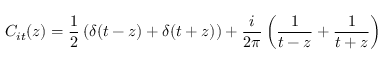Convert formula to latex. <formula><loc_0><loc_0><loc_500><loc_500>C _ { i t } ( z ) = \frac { 1 } { 2 } \left ( \delta ( t - z ) + \delta ( t + z ) \right ) + \frac { i } { 2 \pi } \left ( \frac { 1 } { t - z } + \frac { 1 } { t + z } \right )</formula> 